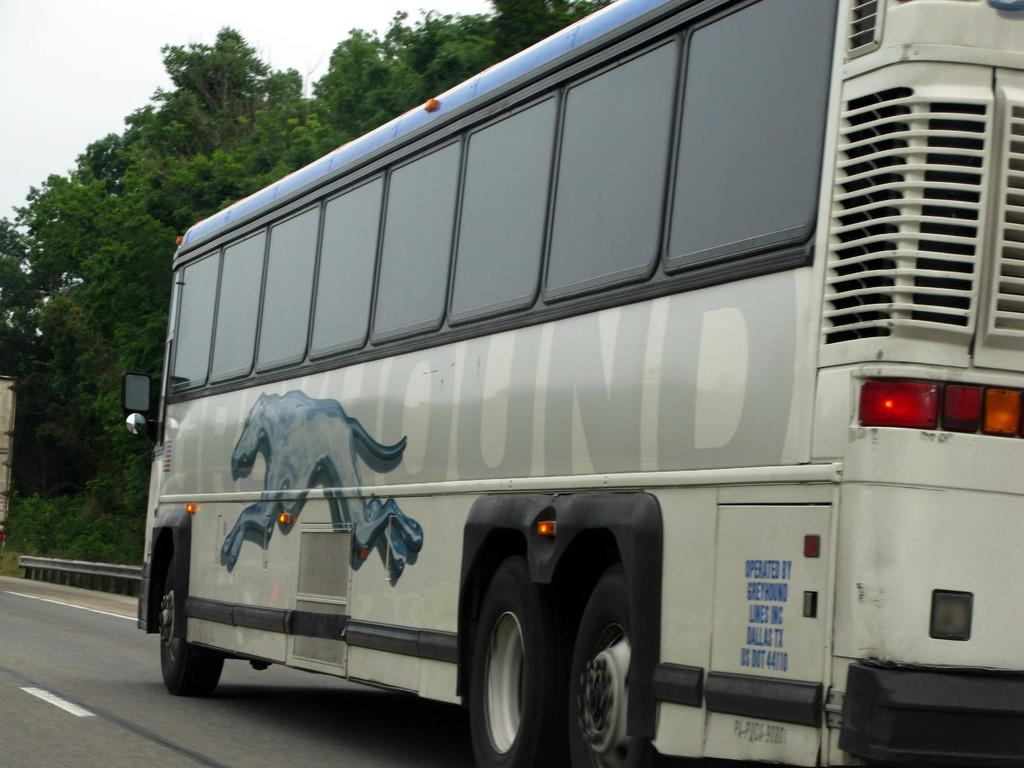What is the main subject of the image? The main subject of the image is a bus. What is the bus doing in the image? The bus is moving on a road in the image. What can be seen in the background of the image? There are trees in the background of the image. What type of clam is being offered by the bus driver in the image? There is no clam or bus driver present in the image; it only features a bus moving on a road. 